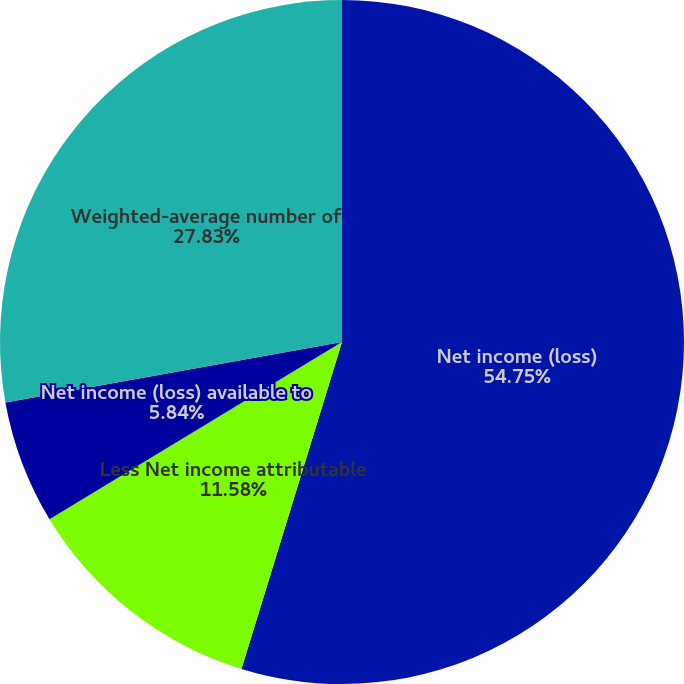Convert chart. <chart><loc_0><loc_0><loc_500><loc_500><pie_chart><fcel>Net income (loss)<fcel>Less Net income attributable<fcel>Net income (loss) available to<fcel>Weighted-average number of<nl><fcel>54.75%<fcel>11.58%<fcel>5.84%<fcel>27.83%<nl></chart> 